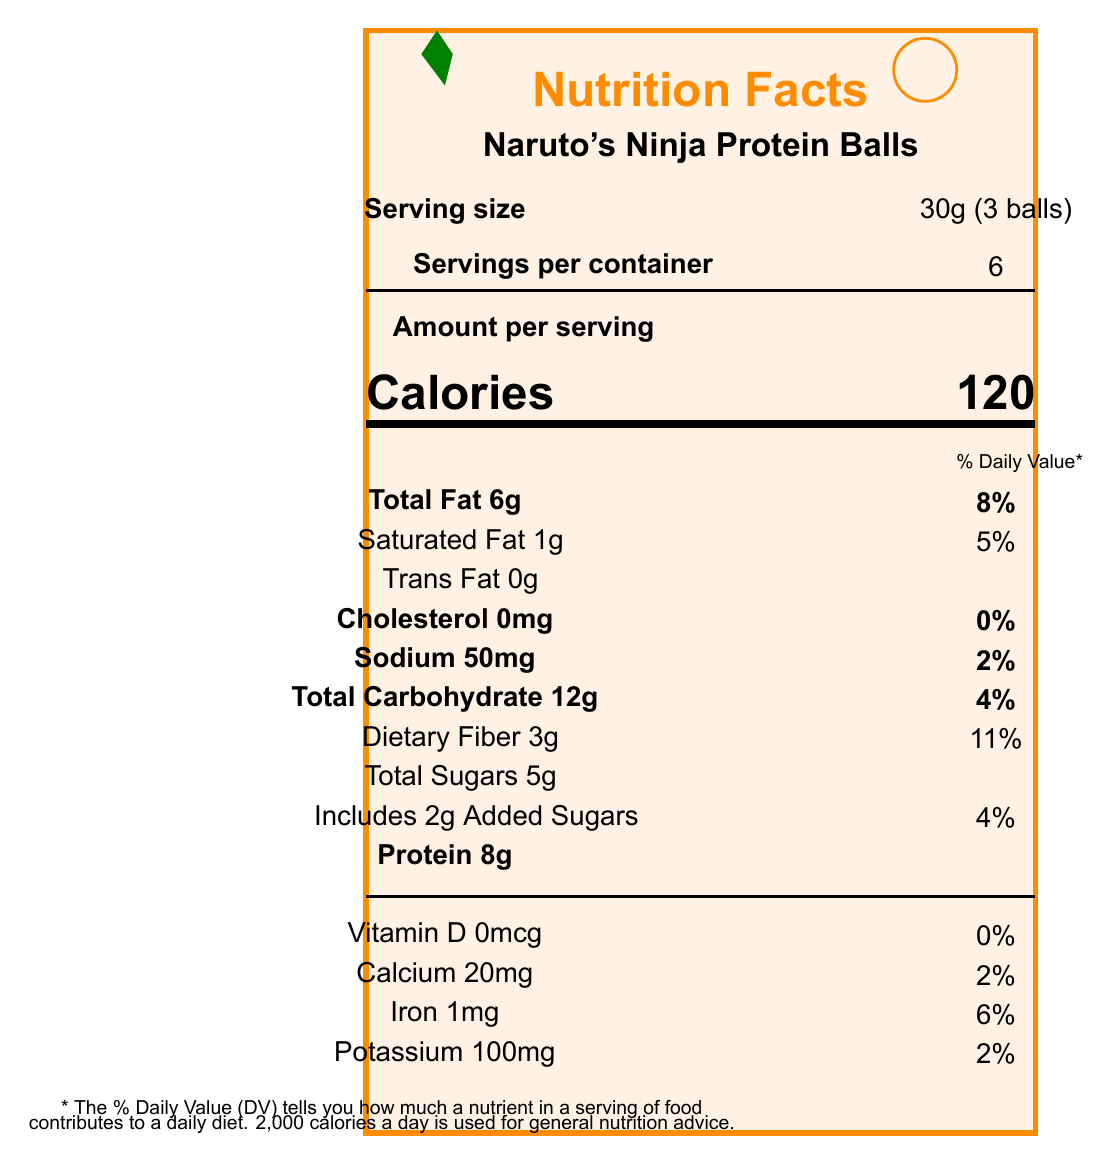what is the serving size? The serving size is explicitly mentioned under the "Serving size" section.
Answer: 30g (3 balls) how many calories are there per serving? The document lists the calorie count as 120 under the "Calories" section.
Answer: 120 what percentage of the daily value for calcium does one serving provide? The calcium content is mentioned as 20mg, which is 2% of the daily value.
Answer: 2% what are the ingredients of Naruto's Ninja Protein Balls? The ingredient list is clearly stated in the document.
Answer: Dates, Almonds, Whey Protein Isolate, Chia Seeds, Cocoa Powder, Natural Orange Flavor how much protein is in one serving? The amount of protein per serving is listed as 8g.
Answer: 8g which nutrient has the highest daily value percentage per serving? A. Total Fat B. Dietary Fiber C. Calcium D. Iron Dietary Fiber has a daily value percentage of 11%, which is the highest listed in the document.
Answer: B. Dietary Fiber how much sodium is there in one container? A. 50mg B. 300mg C. 100mg D. 200mg Each serving contains 50mg of sodium, and there are 6 servings per container, so 50mg x 6 servings = 300mg.
Answer: B. 300mg does this product contain any trans fat? The document indicates that the trans fat content is 0g.
Answer: No are there any artificial sweeteners or preservatives in Naruto's Ninja Protein Balls? The health benefits section specifies that there are no artificial sweeteners or preservatives.
Answer: No summarize the document. The summary encapsulates the key points of the document including the nutritional facts, ingredient list, target audience, health benefits, and distribution strategy.
Answer: Naruto's Ninja Protein Balls are a health-conscious snack inspired by the Naruto manga. Each 30g serving, which consists of 3 balls, contains 120 calories. The product offers high protein (8g), fiber (3g), and low sodium (50mg). Ingredients include natural foods like dates, almonds, and chia seeds. The packaging is sustainable and features a Naruto-inspired design. These snacks are marketed towards young adults and teens, and are available in various niche locations like comic book stores and anime conventions. how many grams of added sugars are there per serving? The "Includes 2g Added Sugars" information is listed under the Total Sugars section.
Answer: 2g which vitamin is not present in this product? The document lists Vitamin D as 0mcg with 0% daily value.
Answer: Vitamin D what is the target audience for this product? The target audience is explicitly stated in the document.
Answer: Young adults and teens who are fans of shounen manga what is the marketing tagline for this product? The marketing tagline is mentioned in the document.
Answer: Power up like a ninja with every bite! where can you buy Naruto's Ninja Protein Balls? The distribution channels are listed in the document.
Answer: Comic book stores, Anime conventions, Health food stores, Online manga retailers what is the total carbohydrate content per serving? The document specifies that the total carbohydrate content is 12g per serving.
Answer: 12g what are the health benefits of this product? The health benefits are listed in the document as provided.
Answer: High in protein for muscle recovery, Good source of fiber for digestive health, No artificial sweeteners or preservatives how much iron is there per container? The nutritional information is listed per serving, and the total per container is not directly provided.
Answer: Not enough information is the document design inspired by any specific manga? The document design is inspired by the Naruto manga, as indicated by the packaging design and marketing sections.
Answer: Yes 